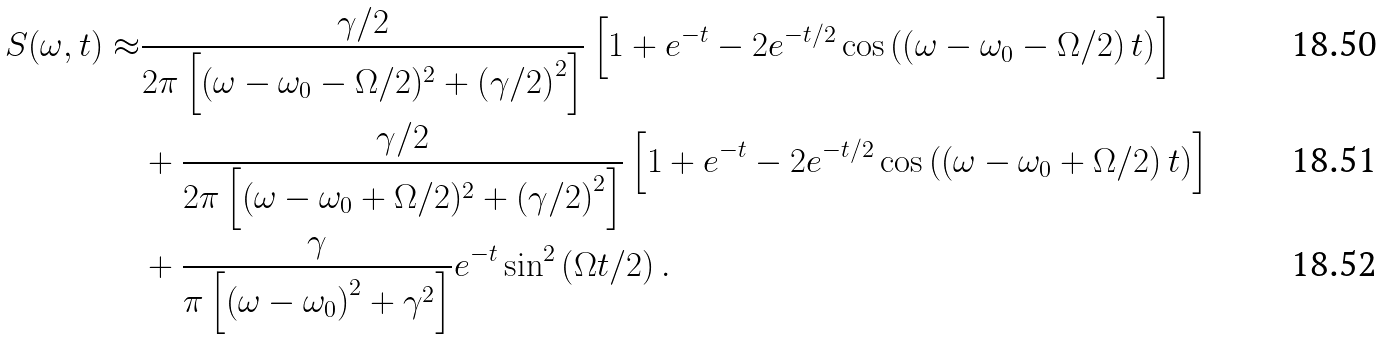<formula> <loc_0><loc_0><loc_500><loc_500>S ( \omega , t ) \approx & \frac { \gamma / 2 } { 2 \pi \left [ ( \omega - \omega _ { 0 } - \Omega / 2 ) ^ { 2 } + \left ( \gamma / 2 \right ) ^ { 2 } \right ] } \left [ 1 + e ^ { - t } - 2 e ^ { - t / 2 } \cos \left ( \left ( \omega - \omega _ { 0 } - \Omega / 2 \right ) t \right ) \right ] \\ & + \frac { \gamma / 2 } { 2 \pi \left [ ( \omega - \omega _ { 0 } + \Omega / 2 ) ^ { 2 } + \left ( \gamma / 2 \right ) ^ { 2 } \right ] } \left [ 1 + e ^ { - t } - 2 e ^ { - t / 2 } \cos \left ( \left ( \omega - \omega _ { 0 } + \Omega / 2 \right ) t \right ) \right ] \\ & + \frac { \gamma } { \pi \left [ \left ( \omega - \omega _ { 0 } \right ) ^ { 2 } + \gamma ^ { 2 } \right ] } e ^ { - t } \sin ^ { 2 } \left ( \Omega t / 2 \right ) .</formula> 